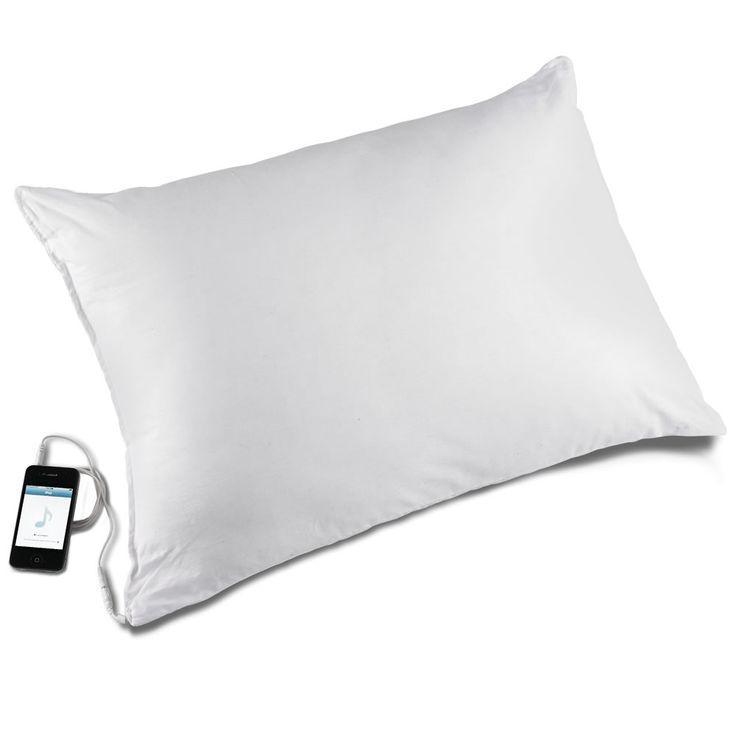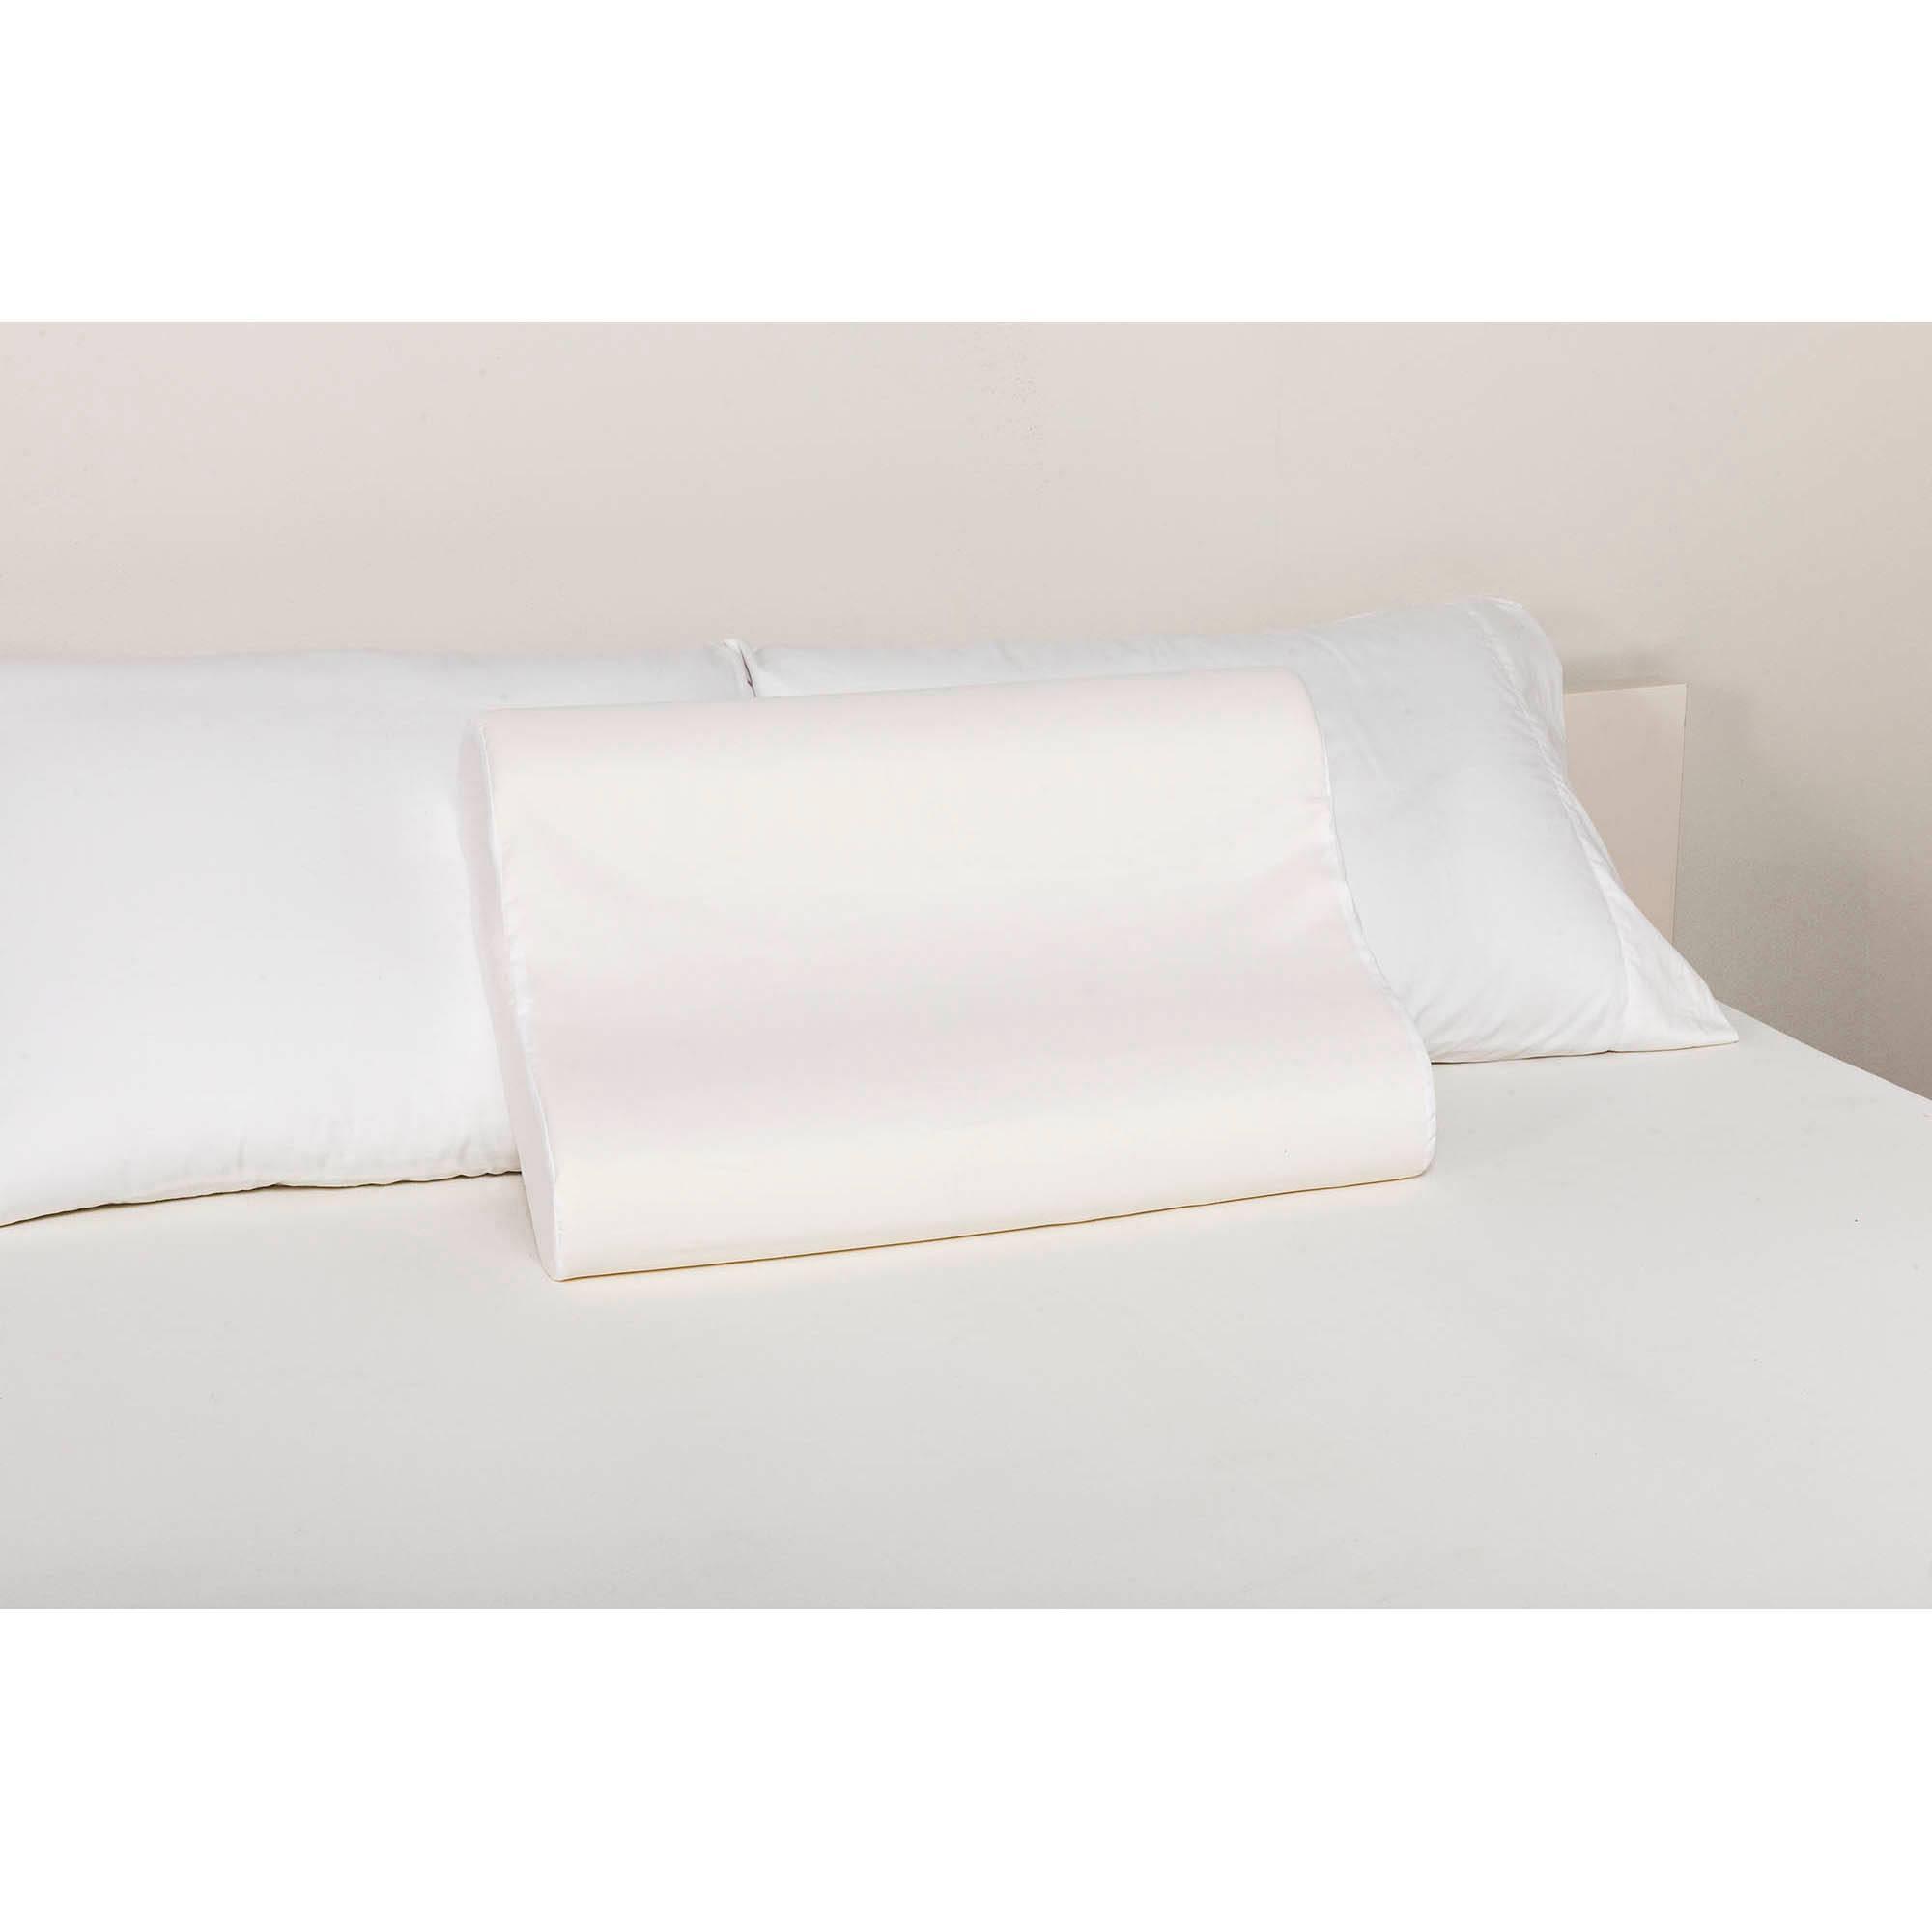The first image is the image on the left, the second image is the image on the right. Evaluate the accuracy of this statement regarding the images: "An image includes a sculpted pillow with a depression for the sleeper's neck.". Is it true? Answer yes or no. Yes. 